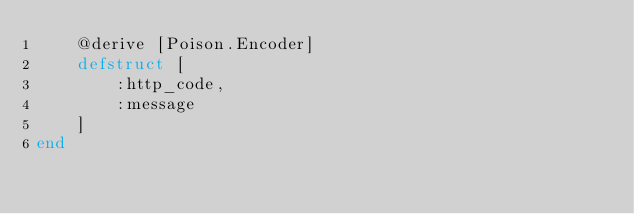Convert code to text. <code><loc_0><loc_0><loc_500><loc_500><_Elixir_>    @derive [Poison.Encoder]
    defstruct [
        :http_code,
        :message
    ]
end
</code> 